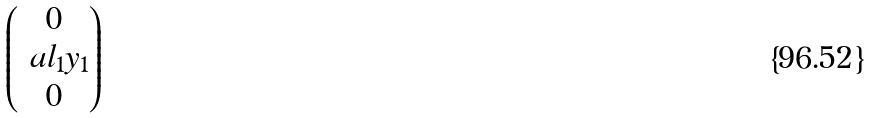<formula> <loc_0><loc_0><loc_500><loc_500>\begin{pmatrix} 0 \\ \ a l _ { 1 } y _ { 1 } \\ 0 \end{pmatrix}</formula> 